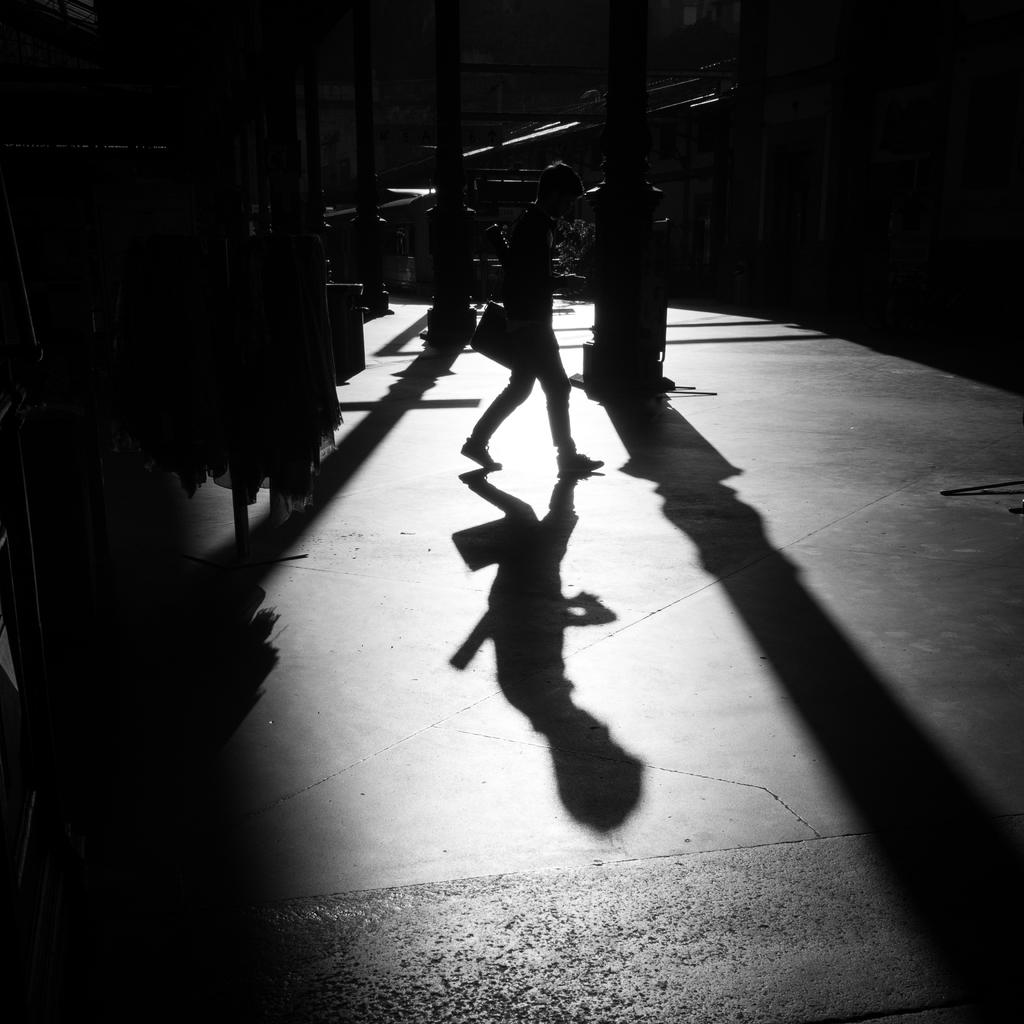What is the person in the image doing? The person is walking in the image. What can be observed about the person's shadow in the image? The person's shadow is visible on the floor. What architectural features are present in the image? There are pillars present in the image. How many nails can be seen in the image? There are no nails visible in the image. What type of sand can be seen on the ground in the image? There is no sand present in the image. 